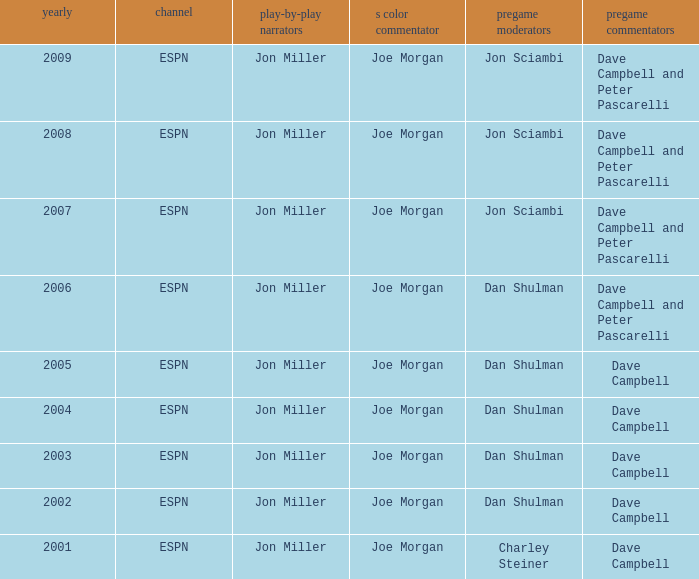Who is the s color commentator when the pregame host is jon sciambi? Joe Morgan, Joe Morgan, Joe Morgan. 